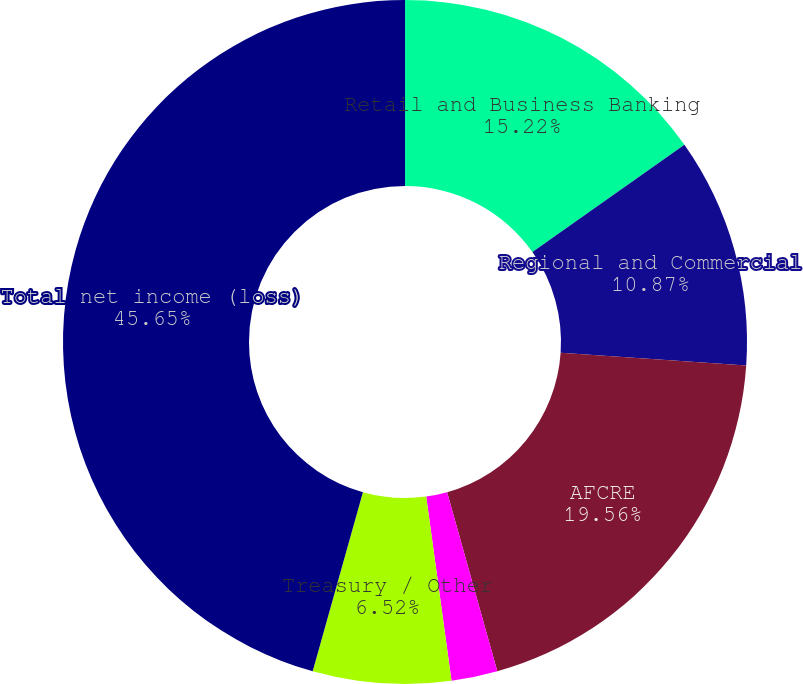Convert chart. <chart><loc_0><loc_0><loc_500><loc_500><pie_chart><fcel>Retail and Business Banking<fcel>Regional and Commercial<fcel>AFCRE<fcel>WGH<fcel>Treasury / Other<fcel>Total net income (loss)<nl><fcel>15.22%<fcel>10.87%<fcel>19.56%<fcel>2.18%<fcel>6.52%<fcel>45.65%<nl></chart> 